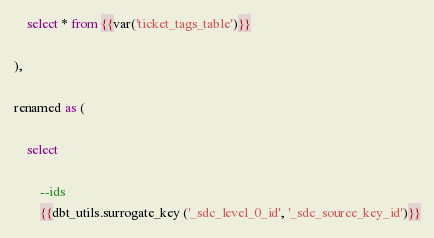<code> <loc_0><loc_0><loc_500><loc_500><_SQL_>    select * from {{var('ticket_tags_table')}}
    
),

renamed as (
    
    select 
    
        --ids
        {{dbt_utils.surrogate_key ('_sdc_level_0_id', '_sdc_source_key_id')}}</code> 